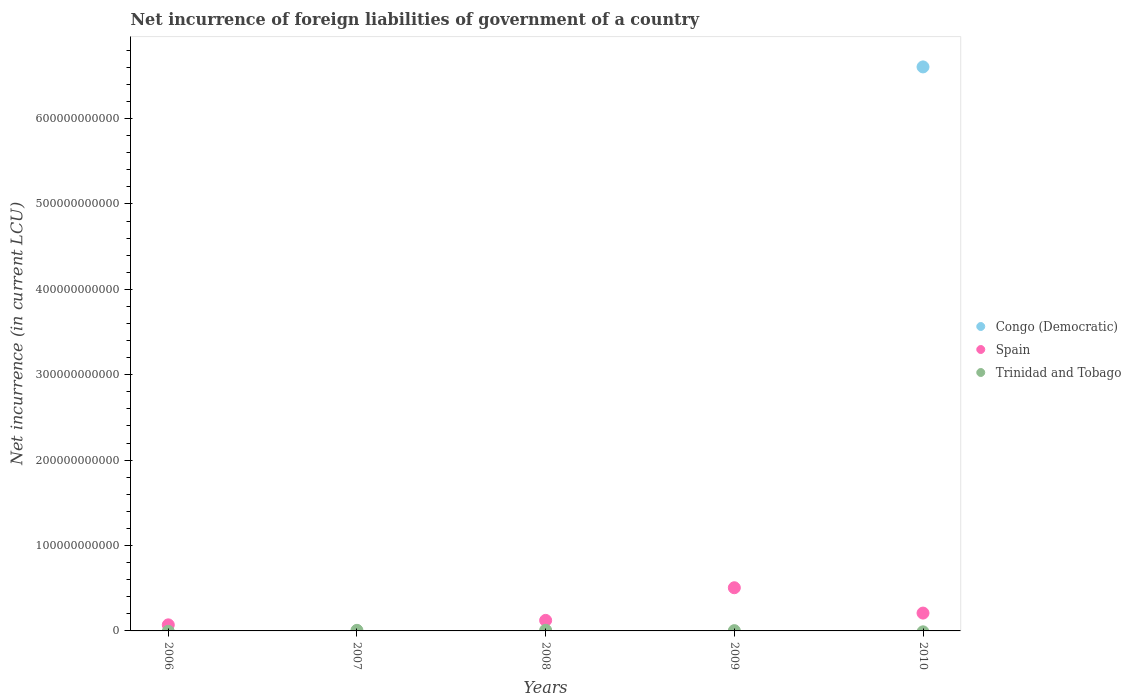How many different coloured dotlines are there?
Provide a short and direct response. 3. Is the number of dotlines equal to the number of legend labels?
Provide a short and direct response. No. Across all years, what is the maximum net incurrence of foreign liabilities in Trinidad and Tobago?
Your answer should be compact. 7.97e+08. Across all years, what is the minimum net incurrence of foreign liabilities in Trinidad and Tobago?
Make the answer very short. 0. In which year was the net incurrence of foreign liabilities in Congo (Democratic) maximum?
Keep it short and to the point. 2010. What is the total net incurrence of foreign liabilities in Trinidad and Tobago in the graph?
Provide a succinct answer. 1.81e+09. What is the difference between the net incurrence of foreign liabilities in Trinidad and Tobago in 2007 and that in 2009?
Your response must be concise. 3.65e+08. What is the difference between the net incurrence of foreign liabilities in Congo (Democratic) in 2007 and the net incurrence of foreign liabilities in Spain in 2010?
Ensure brevity in your answer.  -2.09e+1. What is the average net incurrence of foreign liabilities in Trinidad and Tobago per year?
Provide a short and direct response. 3.62e+08. In the year 2008, what is the difference between the net incurrence of foreign liabilities in Spain and net incurrence of foreign liabilities in Trinidad and Tobago?
Offer a very short reply. 1.15e+1. In how many years, is the net incurrence of foreign liabilities in Trinidad and Tobago greater than 380000000000 LCU?
Keep it short and to the point. 0. What is the ratio of the net incurrence of foreign liabilities in Spain in 2008 to that in 2010?
Keep it short and to the point. 0.59. Is the net incurrence of foreign liabilities in Trinidad and Tobago in 2007 less than that in 2009?
Ensure brevity in your answer.  No. What is the difference between the highest and the second highest net incurrence of foreign liabilities in Trinidad and Tobago?
Provide a succinct answer. 1.08e+08. What is the difference between the highest and the lowest net incurrence of foreign liabilities in Spain?
Offer a very short reply. 5.06e+1. In how many years, is the net incurrence of foreign liabilities in Congo (Democratic) greater than the average net incurrence of foreign liabilities in Congo (Democratic) taken over all years?
Ensure brevity in your answer.  1. Is it the case that in every year, the sum of the net incurrence of foreign liabilities in Spain and net incurrence of foreign liabilities in Congo (Democratic)  is greater than the net incurrence of foreign liabilities in Trinidad and Tobago?
Provide a succinct answer. No. Is the net incurrence of foreign liabilities in Spain strictly greater than the net incurrence of foreign liabilities in Congo (Democratic) over the years?
Provide a short and direct response. No. What is the difference between two consecutive major ticks on the Y-axis?
Provide a succinct answer. 1.00e+11. Are the values on the major ticks of Y-axis written in scientific E-notation?
Your answer should be very brief. No. Where does the legend appear in the graph?
Your answer should be very brief. Center right. What is the title of the graph?
Offer a terse response. Net incurrence of foreign liabilities of government of a country. What is the label or title of the X-axis?
Provide a short and direct response. Years. What is the label or title of the Y-axis?
Make the answer very short. Net incurrence (in current LCU). What is the Net incurrence (in current LCU) of Spain in 2006?
Your answer should be very brief. 7.12e+09. What is the Net incurrence (in current LCU) in Congo (Democratic) in 2007?
Make the answer very short. 0. What is the Net incurrence (in current LCU) in Spain in 2007?
Offer a terse response. 0. What is the Net incurrence (in current LCU) in Trinidad and Tobago in 2007?
Give a very brief answer. 6.88e+08. What is the Net incurrence (in current LCU) of Spain in 2008?
Your answer should be compact. 1.23e+1. What is the Net incurrence (in current LCU) in Trinidad and Tobago in 2008?
Give a very brief answer. 7.97e+08. What is the Net incurrence (in current LCU) of Spain in 2009?
Your answer should be compact. 5.06e+1. What is the Net incurrence (in current LCU) in Trinidad and Tobago in 2009?
Offer a very short reply. 3.23e+08. What is the Net incurrence (in current LCU) of Congo (Democratic) in 2010?
Your answer should be very brief. 6.60e+11. What is the Net incurrence (in current LCU) in Spain in 2010?
Offer a terse response. 2.09e+1. Across all years, what is the maximum Net incurrence (in current LCU) of Congo (Democratic)?
Keep it short and to the point. 6.60e+11. Across all years, what is the maximum Net incurrence (in current LCU) in Spain?
Provide a short and direct response. 5.06e+1. Across all years, what is the maximum Net incurrence (in current LCU) in Trinidad and Tobago?
Give a very brief answer. 7.97e+08. Across all years, what is the minimum Net incurrence (in current LCU) in Spain?
Keep it short and to the point. 0. Across all years, what is the minimum Net incurrence (in current LCU) in Trinidad and Tobago?
Provide a succinct answer. 0. What is the total Net incurrence (in current LCU) in Congo (Democratic) in the graph?
Ensure brevity in your answer.  6.60e+11. What is the total Net incurrence (in current LCU) in Spain in the graph?
Keep it short and to the point. 9.09e+1. What is the total Net incurrence (in current LCU) in Trinidad and Tobago in the graph?
Your response must be concise. 1.81e+09. What is the difference between the Net incurrence (in current LCU) of Spain in 2006 and that in 2008?
Your answer should be very brief. -5.22e+09. What is the difference between the Net incurrence (in current LCU) of Spain in 2006 and that in 2009?
Offer a very short reply. -4.34e+1. What is the difference between the Net incurrence (in current LCU) in Spain in 2006 and that in 2010?
Offer a terse response. -1.38e+1. What is the difference between the Net incurrence (in current LCU) of Trinidad and Tobago in 2007 and that in 2008?
Keep it short and to the point. -1.08e+08. What is the difference between the Net incurrence (in current LCU) in Trinidad and Tobago in 2007 and that in 2009?
Your answer should be compact. 3.65e+08. What is the difference between the Net incurrence (in current LCU) of Spain in 2008 and that in 2009?
Your response must be concise. -3.82e+1. What is the difference between the Net incurrence (in current LCU) of Trinidad and Tobago in 2008 and that in 2009?
Provide a short and direct response. 4.73e+08. What is the difference between the Net incurrence (in current LCU) of Spain in 2008 and that in 2010?
Ensure brevity in your answer.  -8.55e+09. What is the difference between the Net incurrence (in current LCU) of Spain in 2009 and that in 2010?
Provide a short and direct response. 2.97e+1. What is the difference between the Net incurrence (in current LCU) of Spain in 2006 and the Net incurrence (in current LCU) of Trinidad and Tobago in 2007?
Ensure brevity in your answer.  6.43e+09. What is the difference between the Net incurrence (in current LCU) of Spain in 2006 and the Net incurrence (in current LCU) of Trinidad and Tobago in 2008?
Offer a terse response. 6.32e+09. What is the difference between the Net incurrence (in current LCU) in Spain in 2006 and the Net incurrence (in current LCU) in Trinidad and Tobago in 2009?
Offer a terse response. 6.79e+09. What is the difference between the Net incurrence (in current LCU) in Spain in 2008 and the Net incurrence (in current LCU) in Trinidad and Tobago in 2009?
Your answer should be compact. 1.20e+1. What is the average Net incurrence (in current LCU) in Congo (Democratic) per year?
Keep it short and to the point. 1.32e+11. What is the average Net incurrence (in current LCU) of Spain per year?
Give a very brief answer. 1.82e+1. What is the average Net incurrence (in current LCU) in Trinidad and Tobago per year?
Your answer should be compact. 3.62e+08. In the year 2008, what is the difference between the Net incurrence (in current LCU) of Spain and Net incurrence (in current LCU) of Trinidad and Tobago?
Your answer should be very brief. 1.15e+1. In the year 2009, what is the difference between the Net incurrence (in current LCU) in Spain and Net incurrence (in current LCU) in Trinidad and Tobago?
Your answer should be compact. 5.02e+1. In the year 2010, what is the difference between the Net incurrence (in current LCU) in Congo (Democratic) and Net incurrence (in current LCU) in Spain?
Offer a very short reply. 6.40e+11. What is the ratio of the Net incurrence (in current LCU) in Spain in 2006 to that in 2008?
Offer a very short reply. 0.58. What is the ratio of the Net incurrence (in current LCU) of Spain in 2006 to that in 2009?
Your answer should be very brief. 0.14. What is the ratio of the Net incurrence (in current LCU) of Spain in 2006 to that in 2010?
Keep it short and to the point. 0.34. What is the ratio of the Net incurrence (in current LCU) of Trinidad and Tobago in 2007 to that in 2008?
Give a very brief answer. 0.86. What is the ratio of the Net incurrence (in current LCU) in Trinidad and Tobago in 2007 to that in 2009?
Your response must be concise. 2.13. What is the ratio of the Net incurrence (in current LCU) in Spain in 2008 to that in 2009?
Provide a short and direct response. 0.24. What is the ratio of the Net incurrence (in current LCU) of Trinidad and Tobago in 2008 to that in 2009?
Give a very brief answer. 2.46. What is the ratio of the Net incurrence (in current LCU) of Spain in 2008 to that in 2010?
Keep it short and to the point. 0.59. What is the ratio of the Net incurrence (in current LCU) in Spain in 2009 to that in 2010?
Ensure brevity in your answer.  2.42. What is the difference between the highest and the second highest Net incurrence (in current LCU) of Spain?
Make the answer very short. 2.97e+1. What is the difference between the highest and the second highest Net incurrence (in current LCU) of Trinidad and Tobago?
Ensure brevity in your answer.  1.08e+08. What is the difference between the highest and the lowest Net incurrence (in current LCU) of Congo (Democratic)?
Provide a short and direct response. 6.60e+11. What is the difference between the highest and the lowest Net incurrence (in current LCU) in Spain?
Make the answer very short. 5.06e+1. What is the difference between the highest and the lowest Net incurrence (in current LCU) of Trinidad and Tobago?
Give a very brief answer. 7.97e+08. 